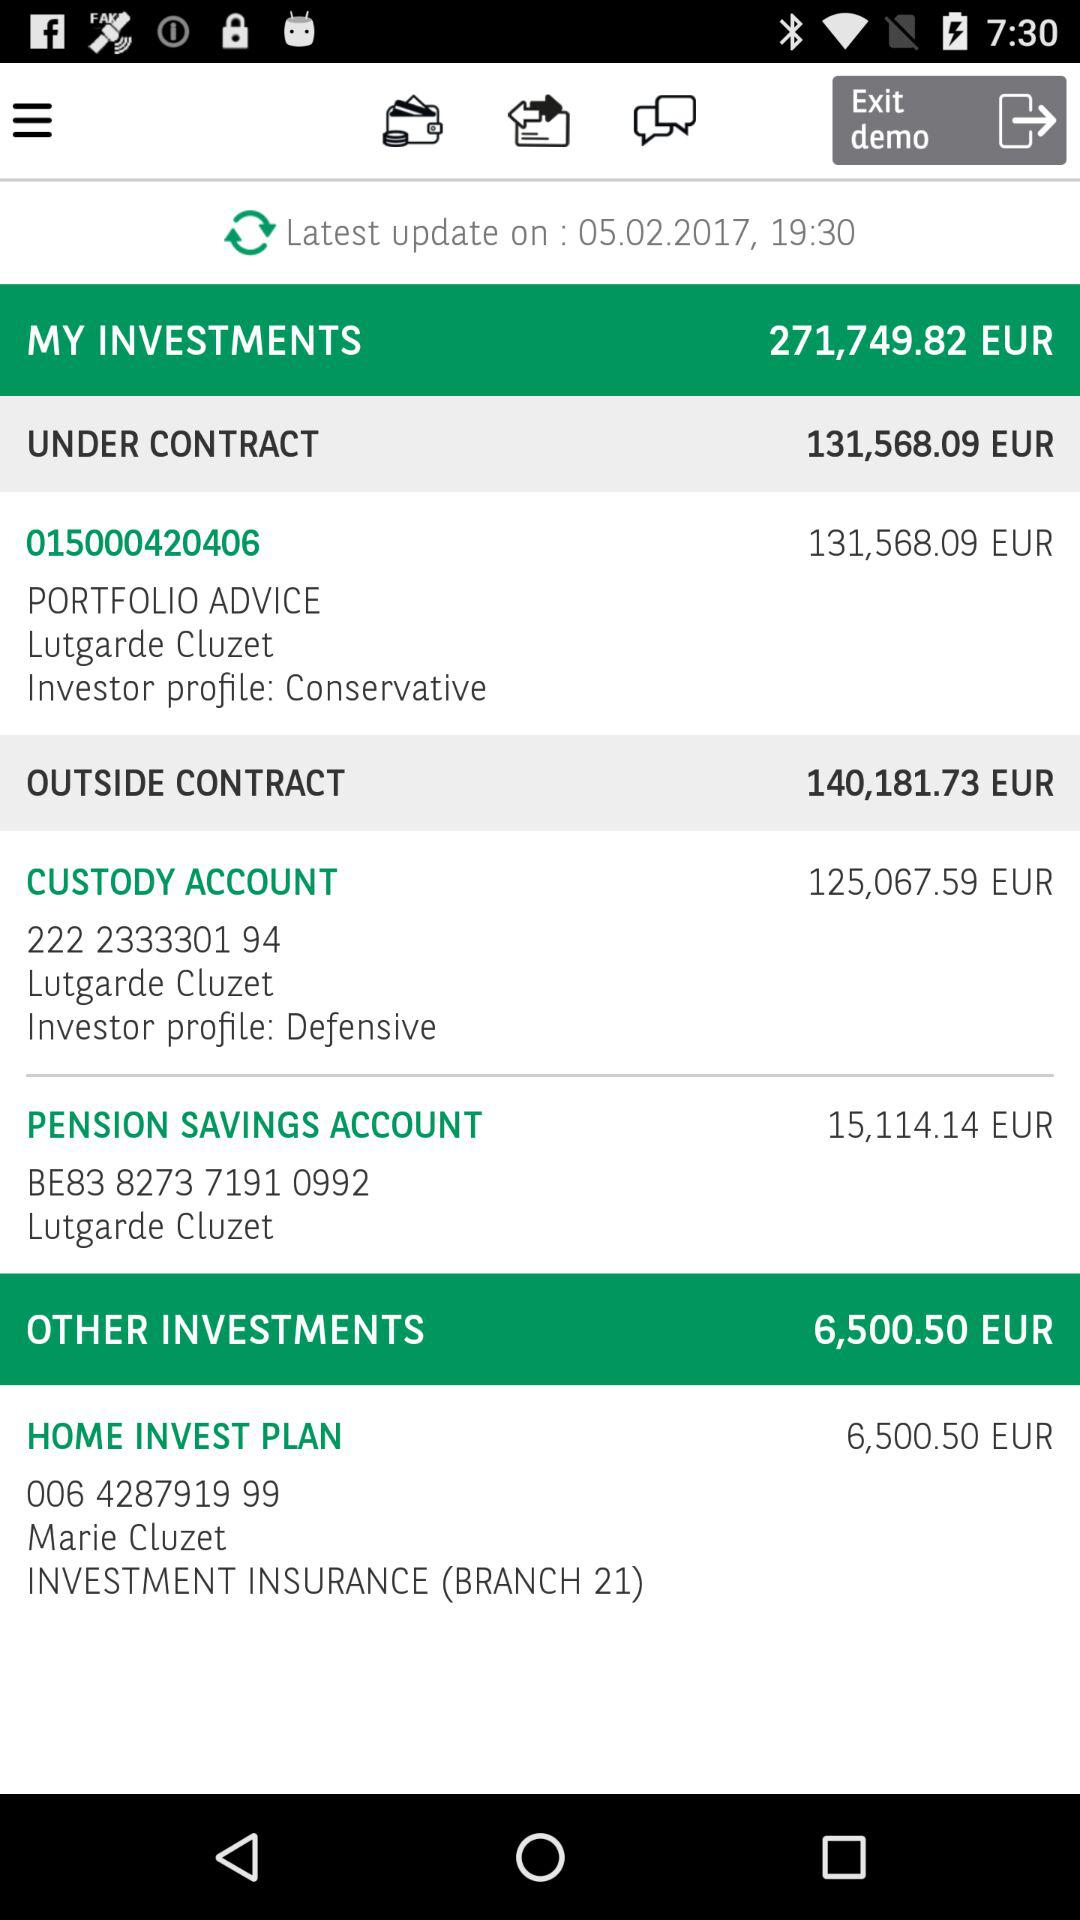How much EUR is in the Custody Account? The EUR in the Custody Account is 140,181.73. 